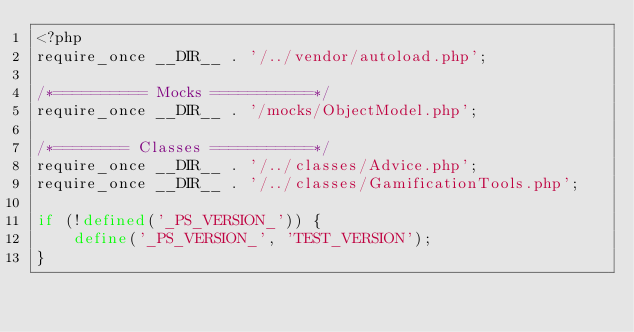Convert code to text. <code><loc_0><loc_0><loc_500><loc_500><_PHP_><?php
require_once __DIR__ . '/../vendor/autoload.php';

/*========== Mocks ===========*/
require_once __DIR__ . '/mocks/ObjectModel.php';

/*======== Classes ===========*/
require_once __DIR__ . '/../classes/Advice.php';
require_once __DIR__ . '/../classes/GamificationTools.php';

if (!defined('_PS_VERSION_')) {
    define('_PS_VERSION_', 'TEST_VERSION');
}
</code> 